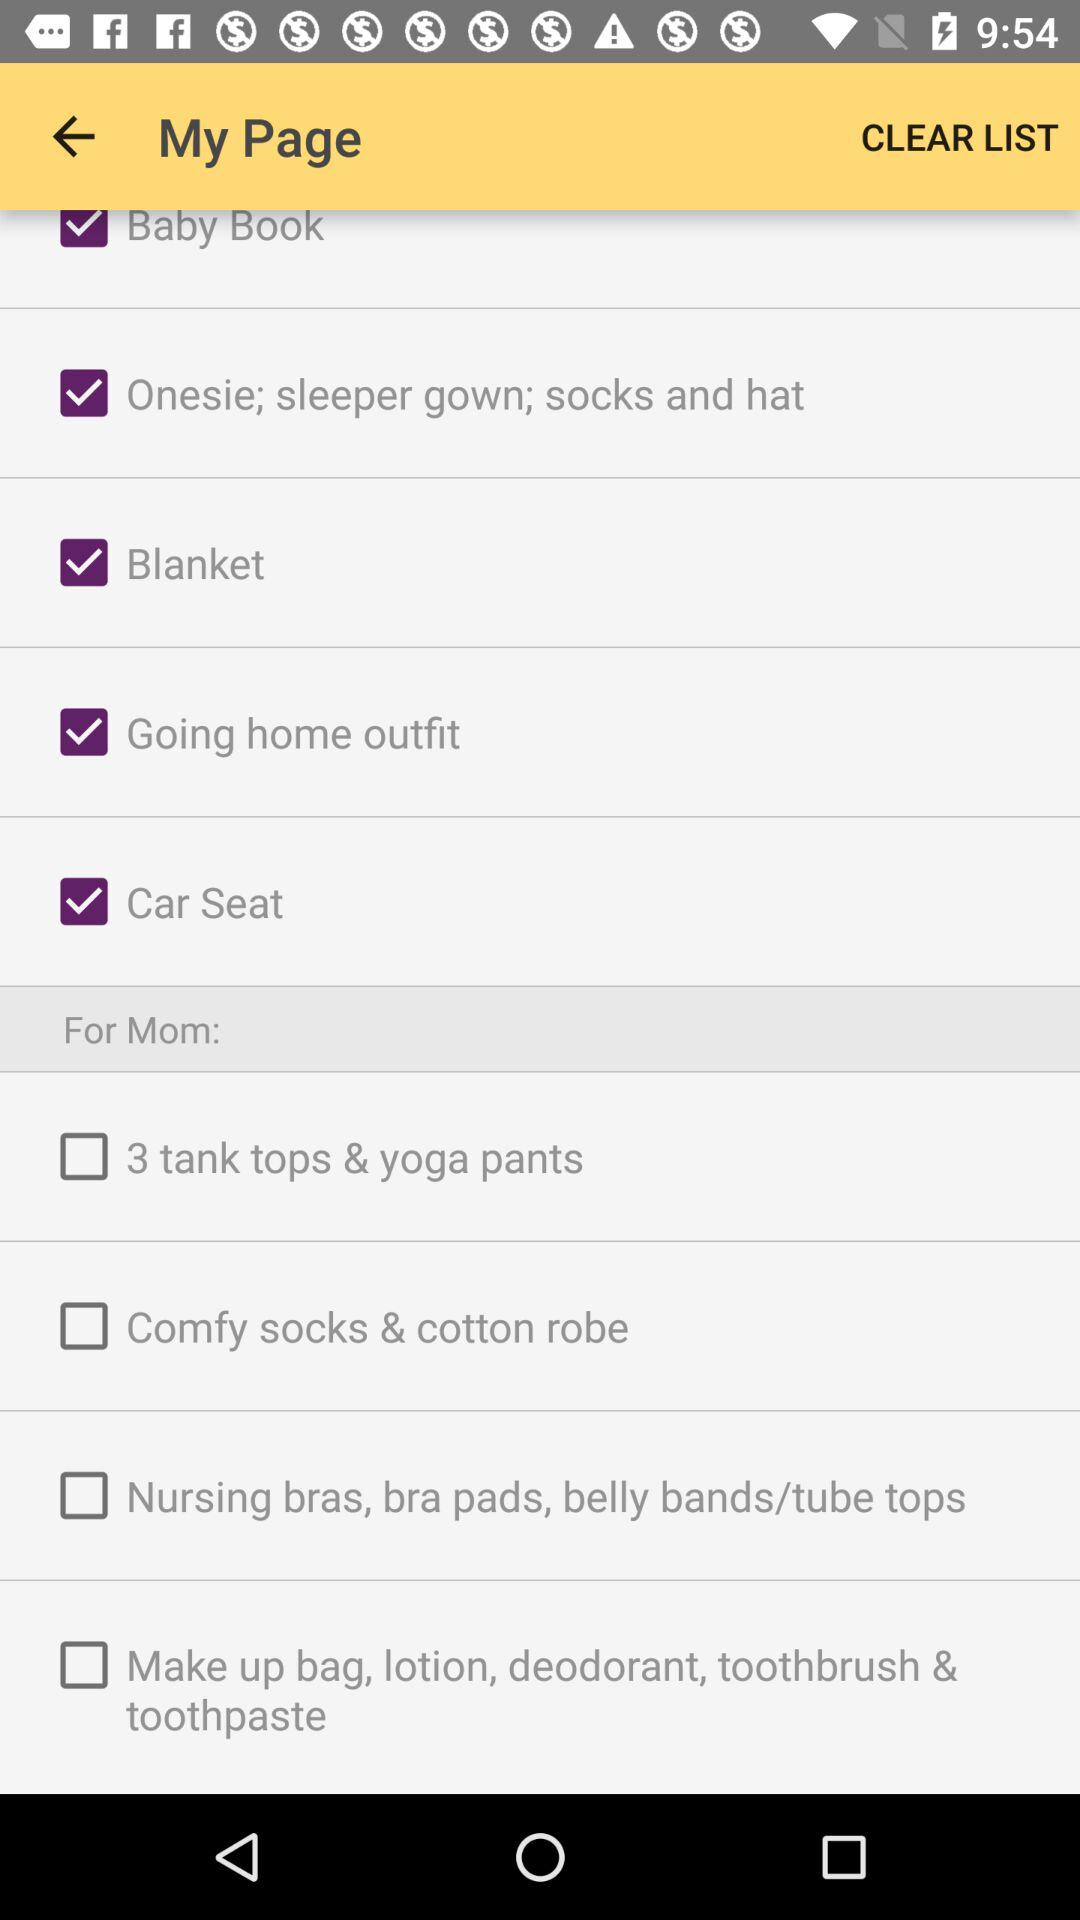What is the status of "Car Seat" checkbox? The status of "Car Seat" checkbox is "on". 